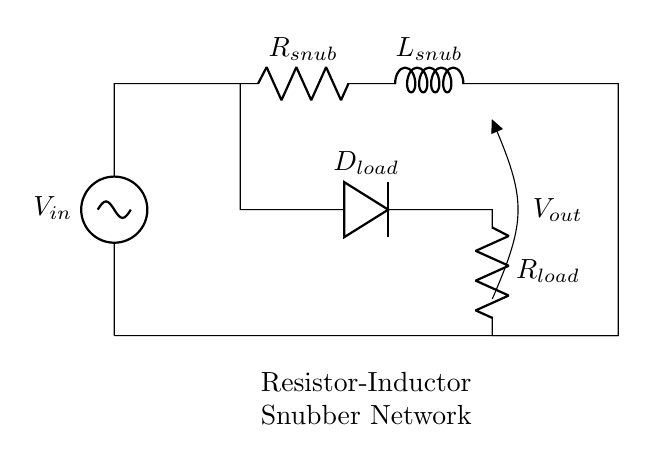What components are in the snubber network? The snubber network consists of a resistor (R_snub) and an inductor (L_snub), which are specifically used to suppress voltage spikes.
Answer: Resistor, Inductor What is the purpose of the diode in this circuit? The diode (D_load) serves to protect the load from reverse voltage and helps maintain current flow, preventing any back EMF from damaging the circuit.
Answer: Protection What is the output voltage labeled as in this circuit? The output voltage is labeled as V_out, which indicates the voltage available at the output terminals of the circuit.
Answer: V_out How are the resistor and inductor connected in the snubber network? The resistor (R_snub) and inductor (L_snub) are connected in series, forming one segment of the overall circuit to mitigate voltage spikes.
Answer: Series What happens to voltage spikes when using this snubber network? The snubber network works to absorb and dampen voltage spikes, reducing their amplitude to prevent possible damage to the load components.
Answer: Suppressed What does the load resistor (R_load) indicate about the circuit's function? The load resistor (R_load) represents the device or component that consumes power from the circuit, showing that the snubber network is integrated into a functional circuit.
Answer: Load consumption 